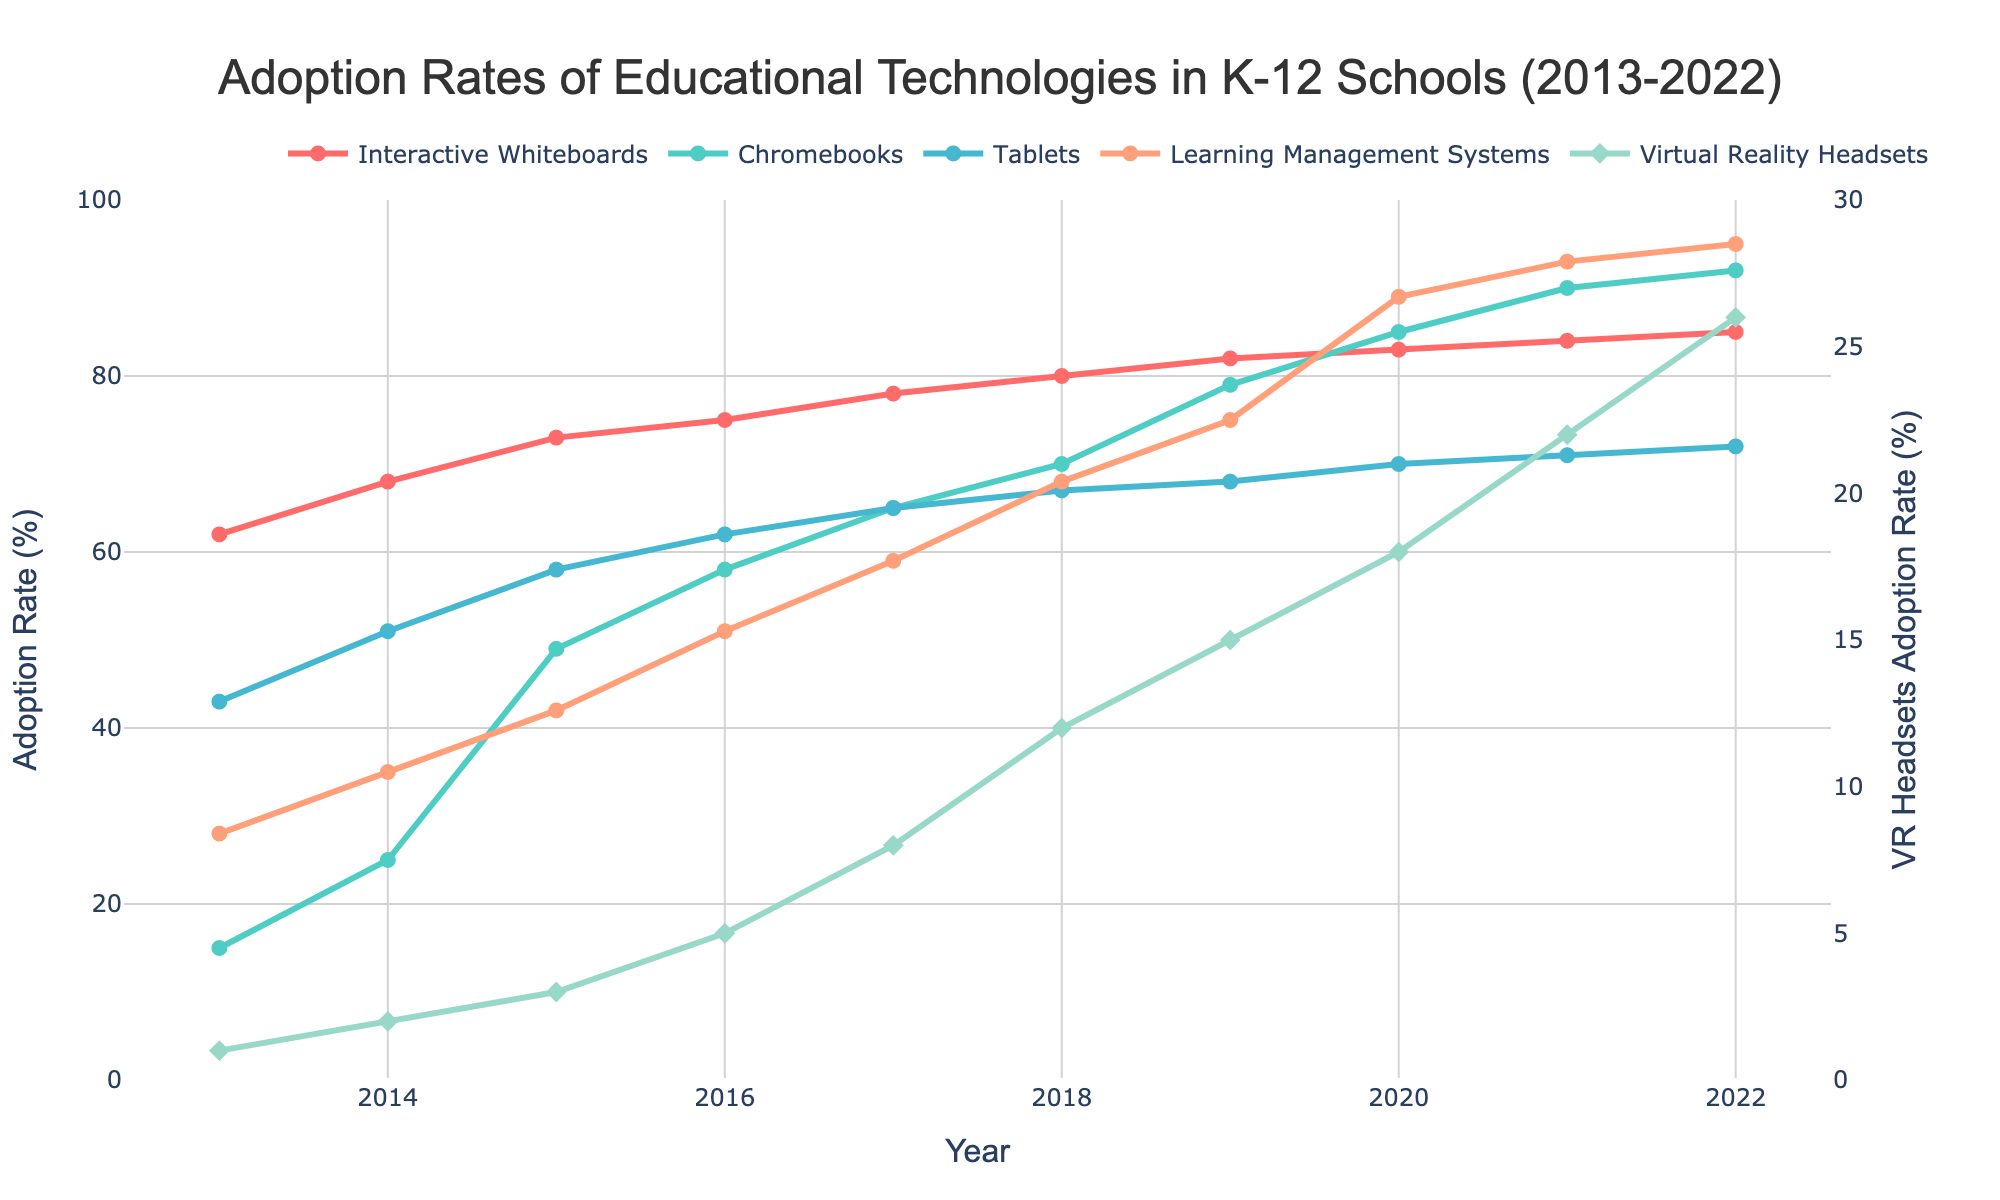What year did Chromebooks surpass a 50% adoption rate? The line for Chromebooks crosses the 50% mark in 2015, as indicated by the corresponding point on the x-axis.
Answer: 2015 Which technology had the highest adoption rate in 2022? Looking at the highest point on the y-axis for 2022, Learning Management Systems reached the highest adoption rate.
Answer: Learning Management Systems How much did the adoption rate of Interactive Whiteboards increase from 2013 to 2022? In 2013, the adoption rate was 62%, and in 2022 it was 85%. The increase is calculated by 85% - 62%.
Answer: 23% Compare the adoption rates of Tablets and Chromebooks in 2020. Which one was higher and by how much? In 2020, Tablets had an adoption rate of 70% and Chromebooks had 85%. The difference is 85% - 70%.
Answer: Chromebooks by 15% Which technology showed a steady increase every year throughout the decade? By observing the continuous upward trend line without any dips, we can see that Interactive Whiteboards showed a steady increase every year.
Answer: Interactive Whiteboards What is the average adoption rate of Virtual Reality Headsets from 2013 to 2022? The adoption rates of Virtual Reality Headsets over the years are [1, 2, 3, 5, 8, 12, 15, 18, 22, 26]. Sum these values and divide by the number of years (10): (1+2+3+5+8+12+15+18+22+26)/10.
Answer: 11.2% What was the adoption rate difference between the highest and lowest technology in 2017? The highest adoption rate in 2017 was Interactive Whiteboards at 78%, and the lowest was Virtual Reality Headsets at 8%. The difference is 78% - 8%.
Answer: 70% Between which two consecutive years did Learning Management Systems see the highest increase in adoption rate? Compare yearly increases for Learning Management Systems: The largest increase is from 2019 (75%) to 2020 (89%), which is 89% - 75%.
Answer: 2019-2020 By what percentage did Tablets' adoption increase from 2014 to 2015? The adoption rate for Tablets in 2014 was 51% and in 2015 was 58%. The increase is calculated as ((58 - 51) / 51) * 100%.
Answer: 13.73% In which year did Virtual Reality Headsets reach double-digit adoption rates for the first time? Virtual Reality Headsets reached double digits in the year 2018, as indicated by the transition to 12%.
Answer: 2018 